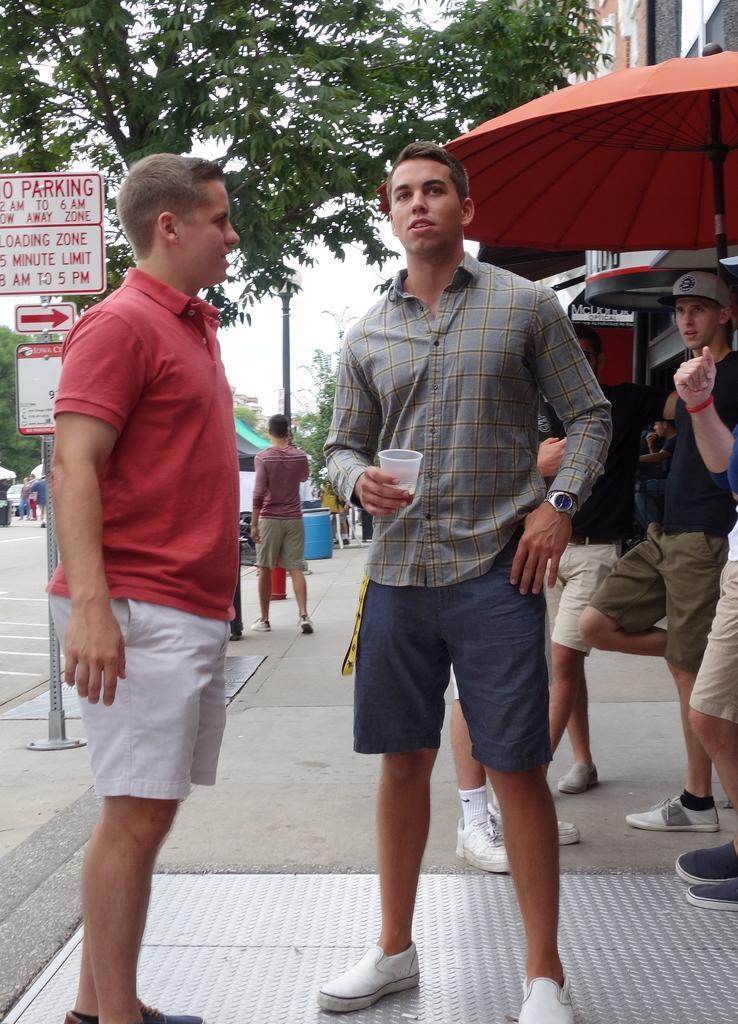Could you give a brief overview of what you see in this image? On the left side, there is a person in orange color t-shirt, standing and smiling. Beside him, there is another person who is holding a glass and standing. In the background, there are other persons, an orange color umbrella, sign boards attached to the pole, road on which, there is a vehicle, trees, a building and there is sky. 